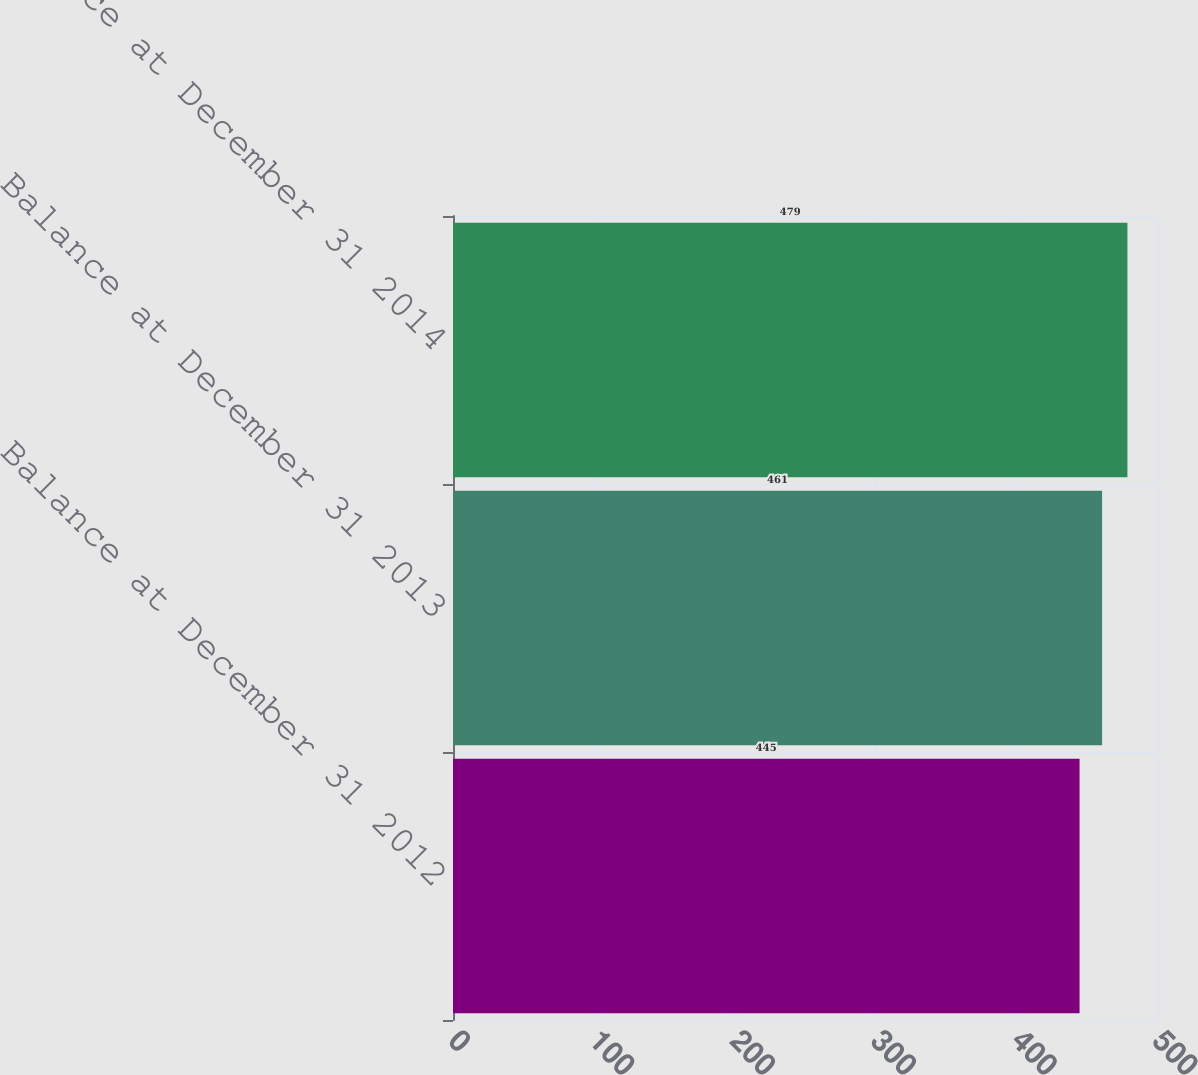Convert chart to OTSL. <chart><loc_0><loc_0><loc_500><loc_500><bar_chart><fcel>Balance at December 31 2012<fcel>Balance at December 31 2013<fcel>Balance at December 31 2014<nl><fcel>445<fcel>461<fcel>479<nl></chart> 